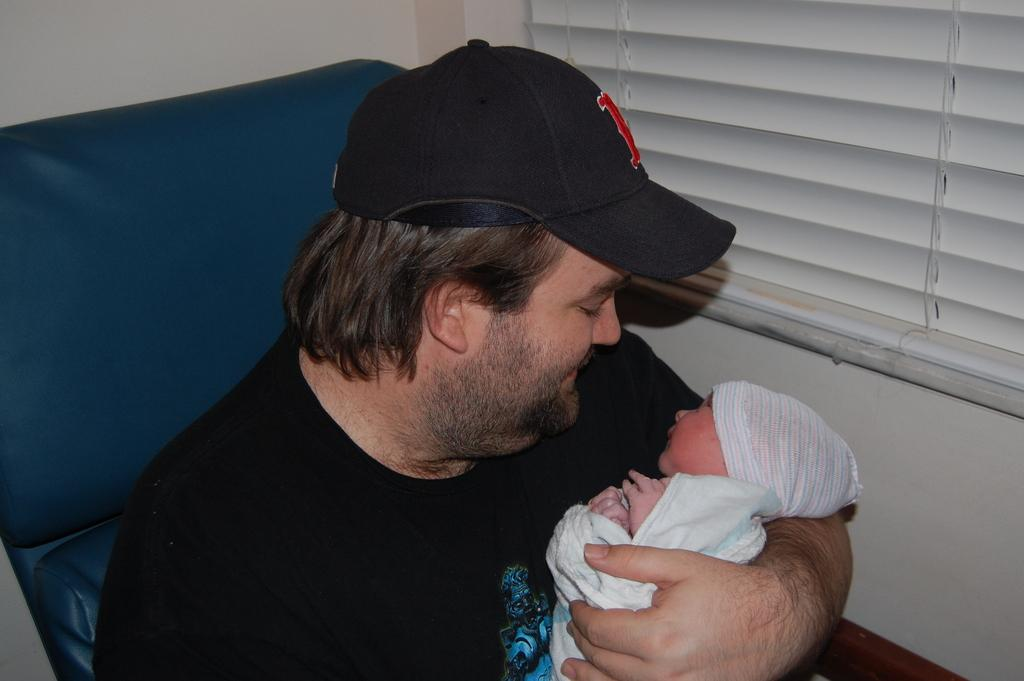Who is present in the image? There is a person and a kid in the image. What can be seen in the background of the image? There is a wall, a window, and a couch in the background of the image. What type of bridge can be seen in the image? There is no bridge present in the image. What color are the eyes of the person in the image? The color of the person's eyes cannot be determined from the image, as their eyes are not visible. 